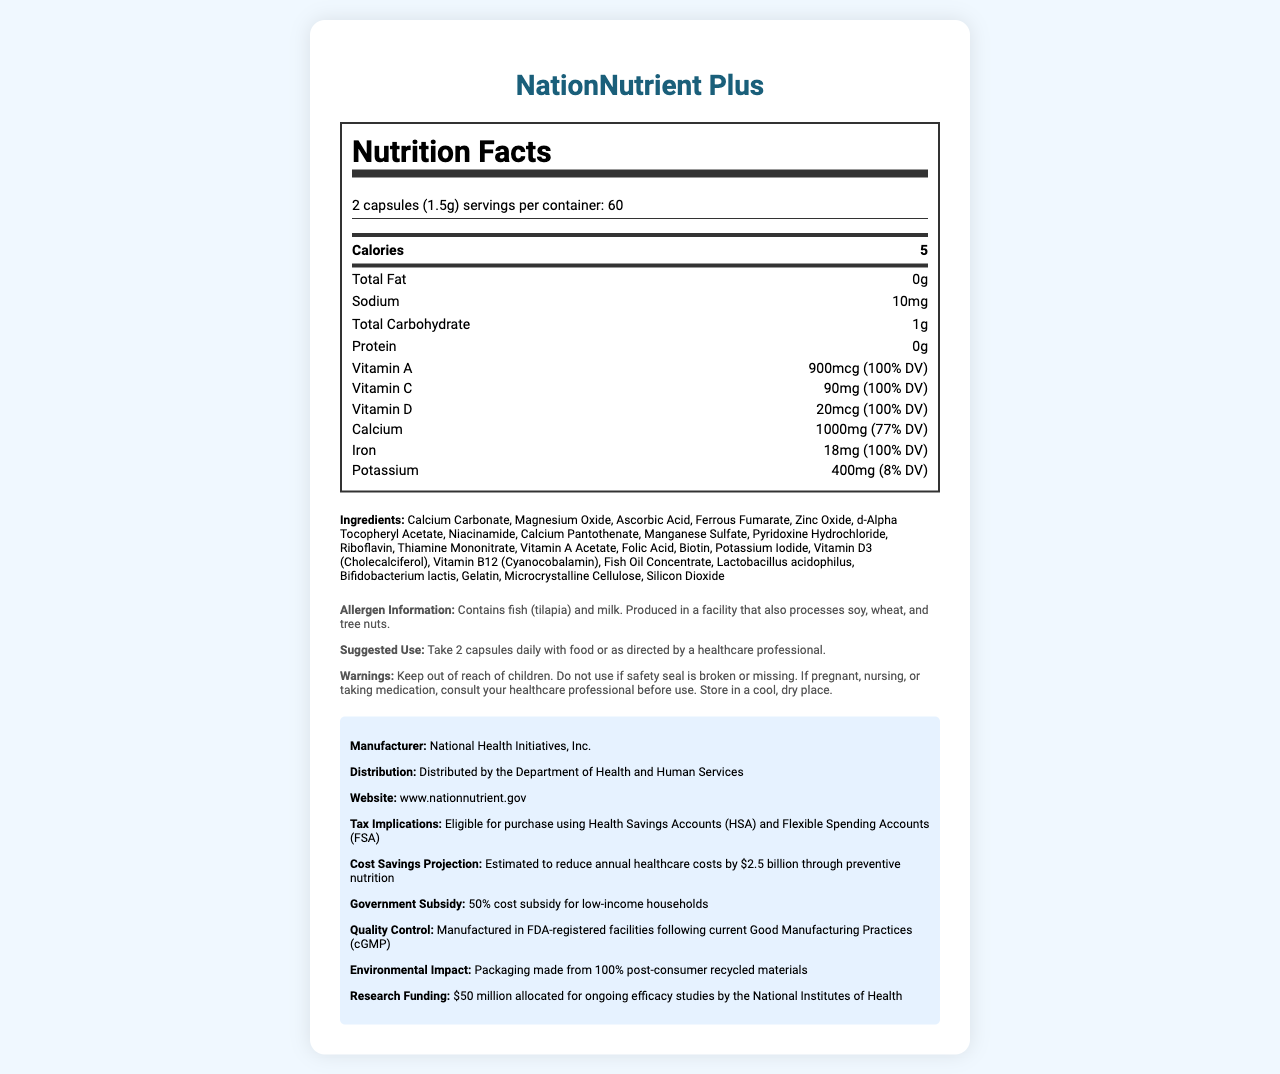who manufactures NationNutrient Plus? The manufacturer is listed in the “government info” section under "Manufacturer."
Answer: National Health Initiatives, Inc. How many capsules make up one serving of NationNutrient Plus? The serving size is indicated as "2 capsules (1.5g)" at the top of the nutrition label.
Answer: 2 capsules What is the daily value percentage of Vitamin D in NationNutrient Plus? The daily value percentage for Vitamin D is shown as "20mcg (100% DV)" in the vitamin row section of the nutrition label.
Answer: 100% What is the recommended usage for NationNutrient Plus? The suggested use is specified in the “additional info” section under "Suggested Use."
Answer: Take 2 capsules daily with food or as directed by a healthcare professional. Does NationNutrient Plus contain any tree nuts? The allergen information specifies that the product contains fish and milk, and it's produced in a facility that processes soy, wheat, and tree nuts, but it doesn't directly contain tree nuts.
Answer: No How many servings are in each container? A. 30 B. 60 C. 90 The servings per container are listed as 60 in the serving info section.
Answer: B. 60 Which vitamin is present at 400mcg DFE in NationNutrient Plus? A. Vitamin A B. Folate C. Vitamin K D. Pantothenic Acid The amount of folate is listed as "400mcg DFE (100% DV)" in the vitamins section.
Answer: B. Folate What type of packaging material is used for NationNutrient Plus? The environmental impact section mentions that the packaging is made from "100% post-consumer recycled materials."
Answer: Post-consumer recycled materials Is it safe to use NationNutrient Plus if the safety seal is broken? One of the warnings states, "Do not use if safety seal is broken or missing."
Answer: No What are all the key features of NationNutrient Plus as per the document? The document includes information about nutrient contents, financial benefits, government subsidy, manufacturing quality, and environmental considerations, making it a comprehensive product overview.
Answer: Nutrition supplement with 100% DV of essential vitamins and minerals, contains omega-3 fatty acids and probiotics, eligible for HSA/FSA, estimated cost savings of $2.5 billion, 50% subsidy for low-income households, manufactured following cGMP, and uses eco-friendly packaging. What is the estimated reduction in annual healthcare costs due to the use of NationNutrient Plus? The "Cost Savings Projection" section states that it is estimated to reduce annual healthcare costs by $2.5 billion.
Answer: $2.5 billion Which of the following nutrients is present in the highest amount in NationNutrient Plus? A. Vitamin D B. Iron C. Zinc D. Calcium Calcium is listed as "1000mg (77% DV)," which is the highest amount among the listed options.
Answer: D. Calcium What type of research funding is provided for NationNutrient Plus? The research funding information states that $50 million has been allocated for ongoing efficacy studies by the NIH.
Answer: $50 million allocated for ongoing efficacy studies by the National Institutes of Health Who distributes NationNutrient Plus? The distribution information lists the Department of Health and Human Services.
Answer: Department of Health and Human Services When should you consult your healthcare professional before using NationNutrient Plus? One of the warnings instructs to consult a healthcare professional if you are pregnant, nursing, or taking medication.
Answer: If pregnant, nursing, or taking medication What is the primary goal of NationNutrient Plus according to the document? The main idea is to deliver essential nutrients and vitamins to help improve public health and reduce overall healthcare expenses, as detailed in the document's financial projection and subsidy sections.
Answer: To provide comprehensive preventive nutrition aiming to reduce annual healthcare costs by $2.5 billion What are the exact sources of omega-3 fatty acids and probiotics in NationNutrient Plus? The document lists "Fish Oil Concentrate" and specific strains of probiotics, but doesn't clarify further details about the exact sources.
Answer: Not enough information 